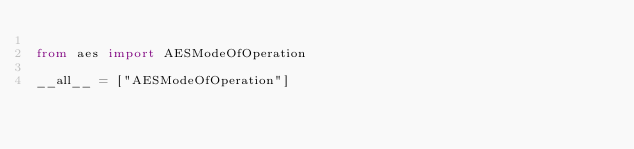<code> <loc_0><loc_0><loc_500><loc_500><_Python_>
from aes import AESModeOfOperation

__all__ = ["AESModeOfOperation"]
</code> 